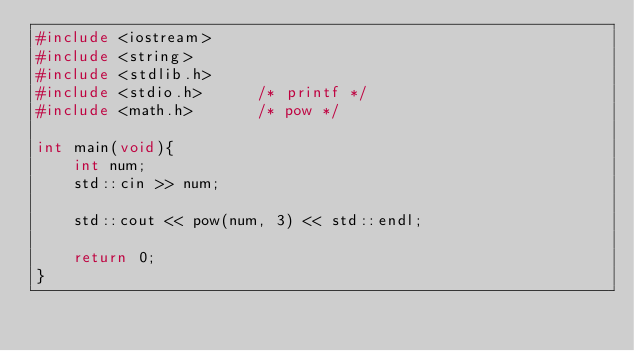<code> <loc_0><loc_0><loc_500><loc_500><_C++_>#include <iostream>
#include <string>
#include <stdlib.h>
#include <stdio.h>      /* printf */
#include <math.h>       /* pow */

int main(void){
    int num;
    std::cin >> num;

    std::cout << pow(num, 3) << std::endl;

    return 0;
}</code> 